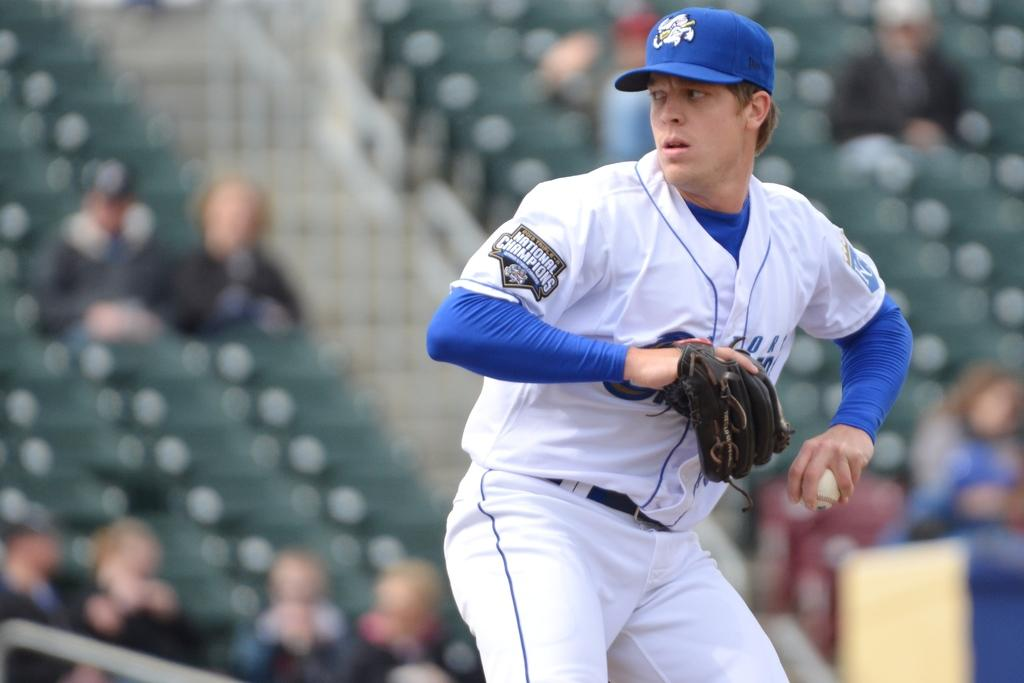<image>
Create a compact narrative representing the image presented. A pitcher wearing a patch saying National Champions gets ready to throw the baseball. 